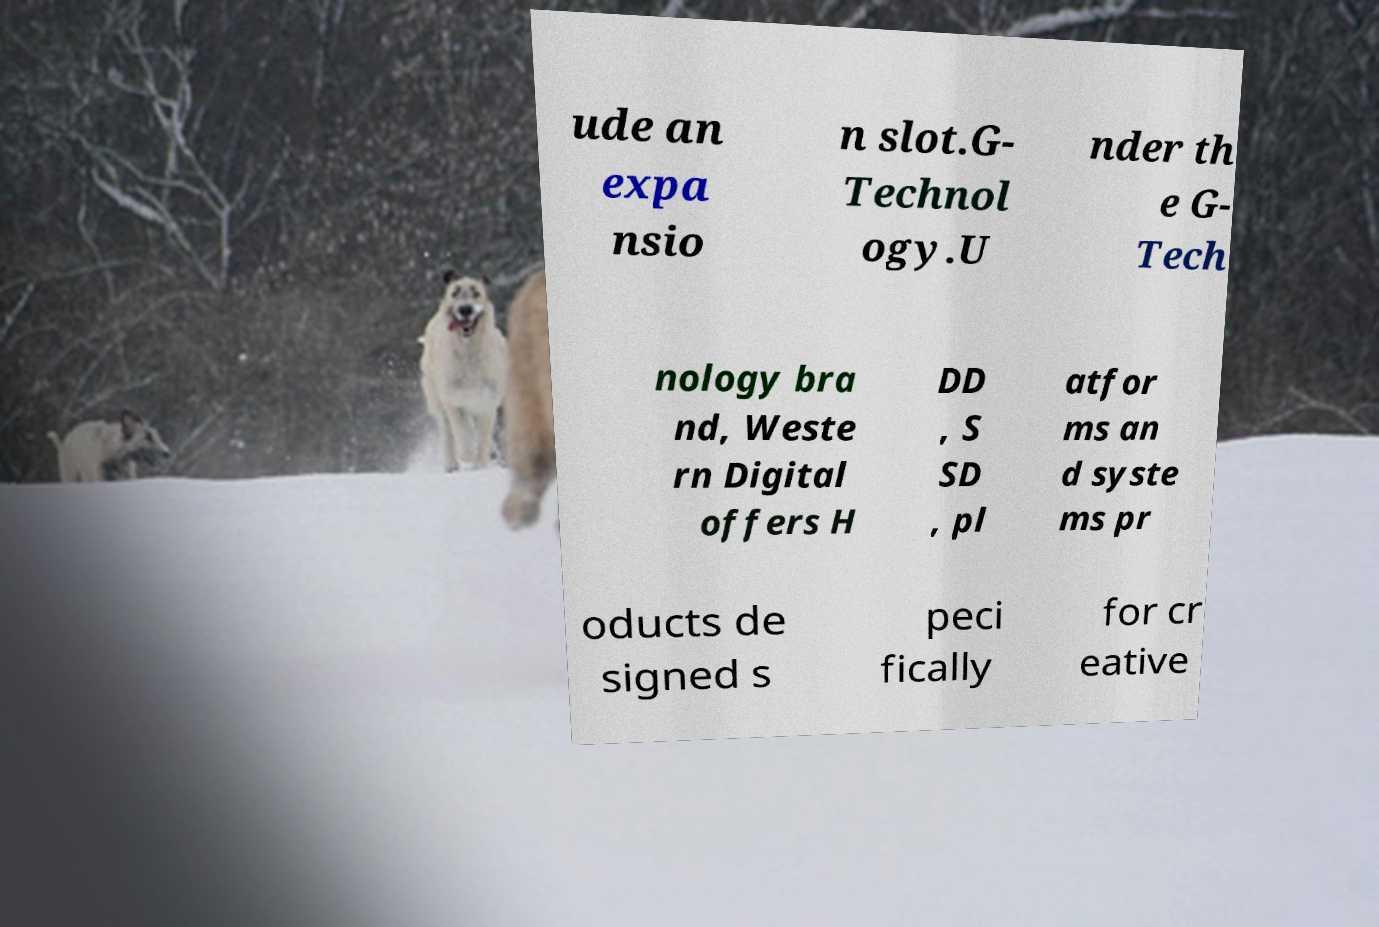Can you read and provide the text displayed in the image?This photo seems to have some interesting text. Can you extract and type it out for me? ude an expa nsio n slot.G- Technol ogy.U nder th e G- Tech nology bra nd, Weste rn Digital offers H DD , S SD , pl atfor ms an d syste ms pr oducts de signed s peci fically for cr eative 